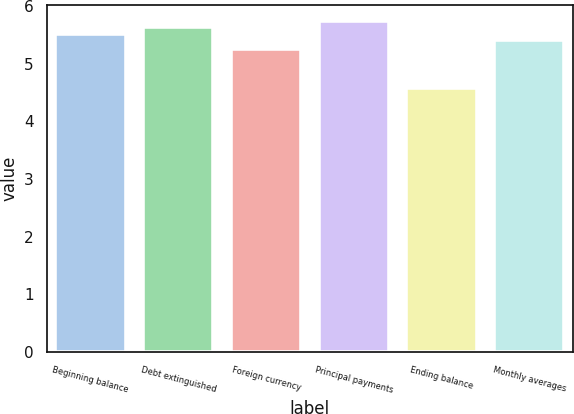<chart> <loc_0><loc_0><loc_500><loc_500><bar_chart><fcel>Beginning balance<fcel>Debt extinguished<fcel>Foreign currency<fcel>Principal payments<fcel>Ending balance<fcel>Monthly averages<nl><fcel>5.52<fcel>5.63<fcel>5.25<fcel>5.74<fcel>4.58<fcel>5.41<nl></chart> 